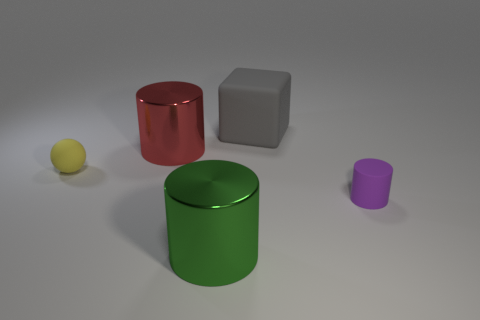The block is what size?
Keep it short and to the point. Large. How many red objects have the same size as the yellow object?
Give a very brief answer. 0. There is a large green thing that is the same shape as the small purple rubber thing; what material is it?
Give a very brief answer. Metal. The object that is both behind the small yellow sphere and on the right side of the green cylinder has what shape?
Keep it short and to the point. Cube. What shape is the object that is right of the large rubber thing?
Your response must be concise. Cylinder. What number of cylinders are both on the right side of the big gray thing and in front of the matte cylinder?
Your answer should be very brief. 0. There is a matte sphere; is it the same size as the red metal cylinder in front of the large gray matte object?
Offer a terse response. No. How big is the rubber thing that is behind the large shiny cylinder behind the tiny object left of the purple cylinder?
Give a very brief answer. Large. How big is the gray cube to the left of the small cylinder?
Offer a terse response. Large. What shape is the gray thing that is made of the same material as the sphere?
Your response must be concise. Cube. 